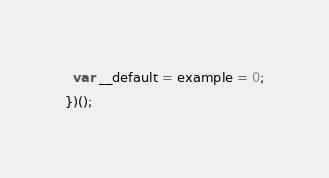Convert code to text. <code><loc_0><loc_0><loc_500><loc_500><_JavaScript_>  var __default = example = 0;
})();
</code> 